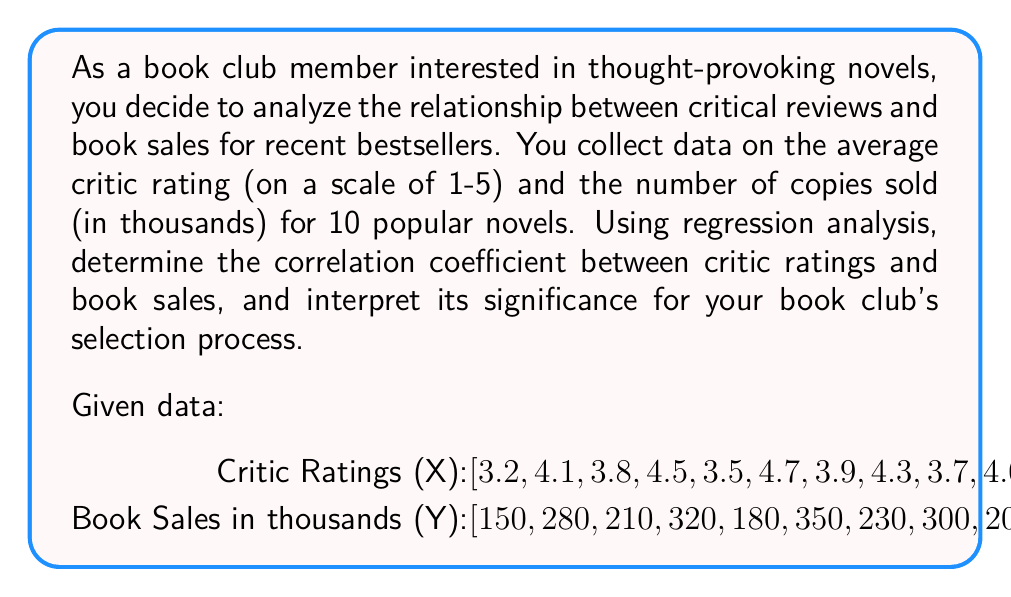Can you solve this math problem? To analyze the correlation between book sales and critical reviews using regression analysis, we'll follow these steps:

1. Calculate the means of X and Y:
   $\bar{X} = \frac{\sum X_i}{n} = \frac{39.7}{10} = 3.97$
   $\bar{Y} = \frac{\sum Y_i}{n} = \frac{2480}{10} = 248$

2. Calculate the variances of X and Y:
   $S_X^2 = \frac{\sum (X_i - \bar{X})^2}{n-1}$
   $S_Y^2 = \frac{\sum (Y_i - \bar{Y})^2}{n-1}$

3. Calculate the covariance of X and Y:
   $S_{XY} = \frac{\sum (X_i - \bar{X})(Y_i - \bar{Y})}{n-1}$

4. Calculate the correlation coefficient:
   $r = \frac{S_{XY}}{\sqrt{S_X^2 \cdot S_Y^2}}$

Calculations:

$\sum (X_i - \bar{X})^2 = 1.7291$
$\sum (Y_i - \bar{Y})^2 = 45,600$
$\sum (X_i - \bar{X})(Y_i - \bar{Y}) = 264.3$

$S_X^2 = \frac{1.7291}{9} = 0.1921$
$S_Y^2 = \frac{45,600}{9} = 5,066.67$
$S_{XY} = \frac{264.3}{9} = 29.37$

$r = \frac{29.37}{\sqrt{0.1921 \cdot 5,066.67}} = 0.9409$

The correlation coefficient is approximately 0.9409, which indicates a strong positive correlation between critic ratings and book sales.

Interpretation:
A correlation coefficient of 0.9409 suggests that there is a strong positive linear relationship between critic ratings and book sales. This means that as critic ratings increase, book sales tend to increase as well. For your book club, this implies that critically acclaimed novels are likely to be more popular and widely read, which could be a valuable consideration when selecting thought-provoking novels for discussion.
Answer: The correlation coefficient between critic ratings and book sales is approximately 0.9409, indicating a strong positive correlation. 